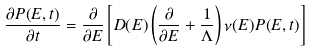Convert formula to latex. <formula><loc_0><loc_0><loc_500><loc_500>\frac { \partial P ( E , t ) } { \partial t } = \frac { \partial } { \partial E } \left [ D ( E ) \left ( \frac { \partial } { \partial E } + \frac { 1 } { \Lambda } \right ) \nu ( E ) P ( E , t ) \right ]</formula> 